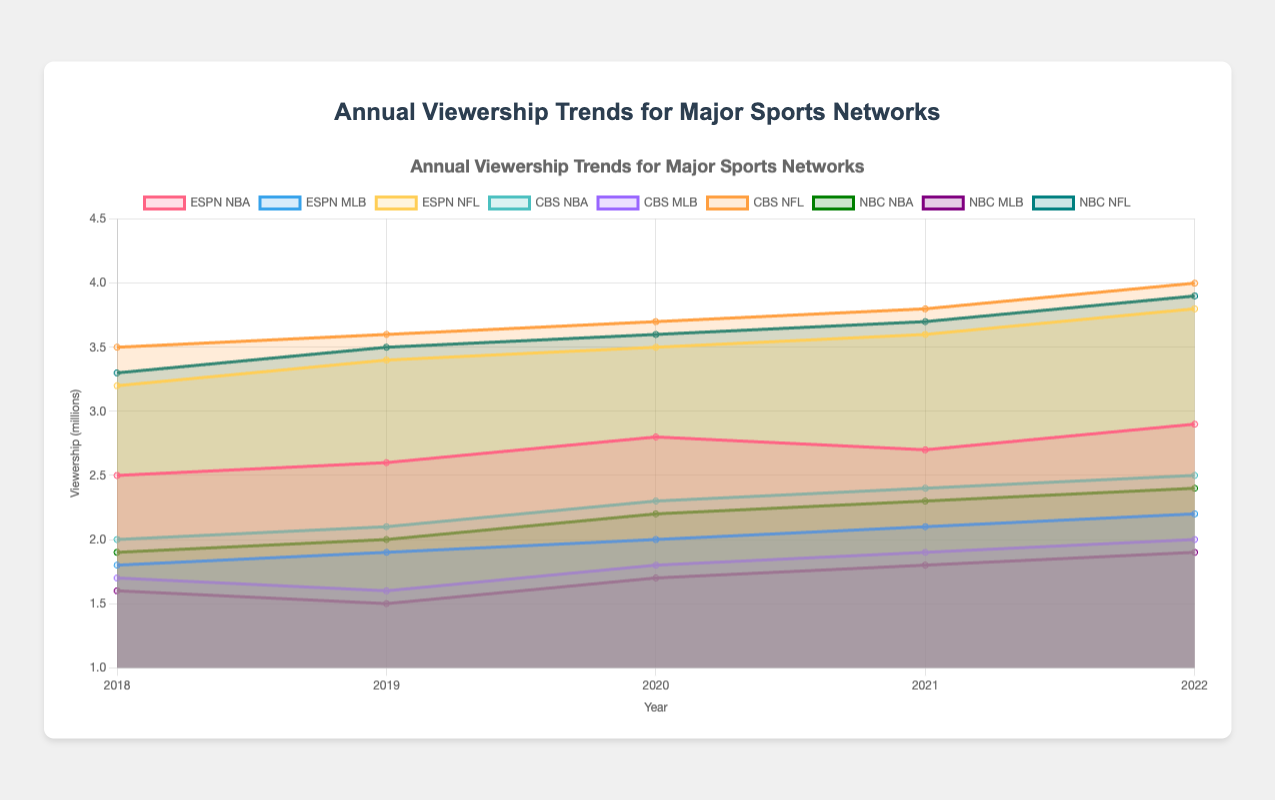What's the most-watched sport on CBS in 2022? The most-watched sport on CBS in 2022 can be identified by looking at the highest data point for CBS in 2022. For CBS in 2022, NBA has 2.5 million, MLB has 2.0 million, and NFL has 4.0 million viewers.
Answer: NFL What's the trend in viewership for ESPN's MLB from 2018 to 2022? The trend can be determined by observing the data points for ESPN's MLB from 2018 to 2022. The viewership for ESPN's MLB in millions is: 1.8 (2018), 1.9 (2019), 2.0 (2020), 2.1 (2021), 2.2 (2022). It's an increasing trend.
Answer: Increasing How do the viewerships of ESPN NBA and CBS NBA compare in 2020? By looking at the data points for 2020, the viewership for ESPN NBA is 2.8 million, and for CBS NBA is 2.3 million.
Answer: ESPN NBA has higher viewership Between 2018 and 2022, did NBC's NBA viewership ever surpass ESPN's NFL viewership in any year? To answer this, compare NBC NBA and ESPN NFL viewership for each year from 2018 to 2022. NBC NBA never surpasses ESPN NFL: NBC NBA (1.9, 2.0, 2.2, 2.3, 2.4) vs. ESPN NFL (3.2, 3.4, 3.5, 3.6, 3.8).
Answer: No What is the overall trend in NFL viewership for both CBS and NBC from 2018 to 2022? To determine the trend, observe the viewership data for CBS and NBC NFL: CBS NFL (3.5, 3.6, 3.7, 3.8, 4.0) and NBC NFL (3.3, 3.5, 3.6, 3.7, 3.9). Both display an increasing trend.
Answer: Increasing for both Which year did ESPN see a decline in NBA viewership and what was the comparison with the previous year? Comparing yearly data for ESPN NBA: 2.5 (2018), 2.6 (2019), 2.8 (2020), 2.7 (2021), 2.9 (2022). ESPN's NBA viewership declined in 2021 compared to 2020 (2.7 million in 2021 vs. 2.8 million in 2020).
Answer: 2021; declined by 0.1 million What were the total viewership numbers for CBS across all sports in 2021? Sum the viewership for CBS NBA, CBS MLB, and CBS NFL in 2021: 2.4 (NBA) + 1.9 (MLB) + 3.8 (NFL) = 8.1 million.
Answer: 8.1 million Which network had the highest overall NBA viewership in 2022? Compare NBA viewership across networks for 2022: ESPN NBA (2.9 million), CBS NBA (2.5 million), NBC NBA (2.4 million). ESPN had the highest viewership.
Answer: ESPN 